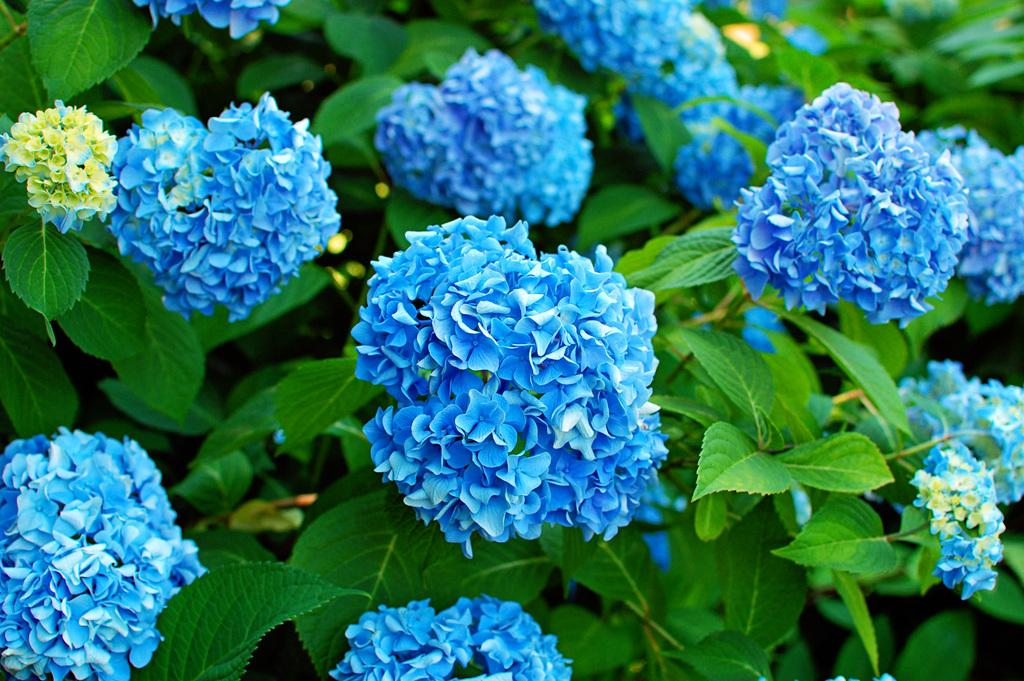What type of plants are visible in the image? There are floral plants in the image. How many cherries are hanging from the tin in the image? There is no tin or cherries present in the image; it only features floral plants. 